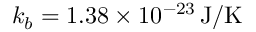Convert formula to latex. <formula><loc_0><loc_0><loc_500><loc_500>k _ { b } = 1 . 3 8 \times 1 0 ^ { - 2 3 } \, J / K</formula> 